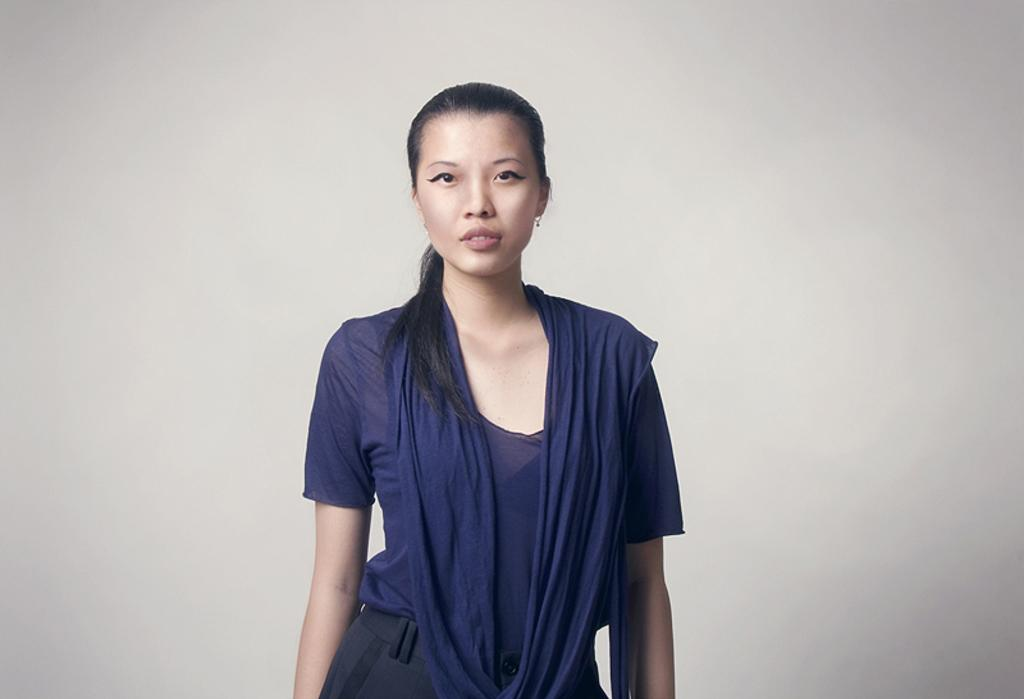What is the main subject of the image? There is a lady standing in the center of the image. Can you describe the background of the image? There is a wall in the background of the image. What type of feather is the lady holding in the image? There is no feather present in the image; the lady is not holding anything. 